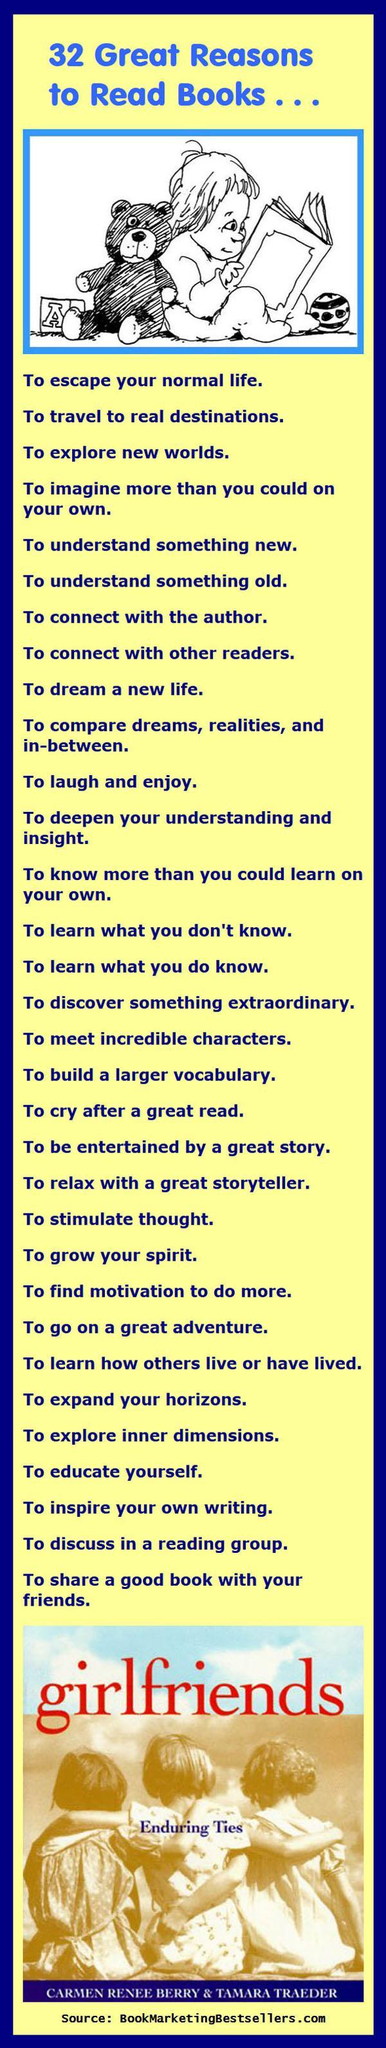How many girls are shown in the photograph girlfriends?
Answer the question with a short phrase. 3 